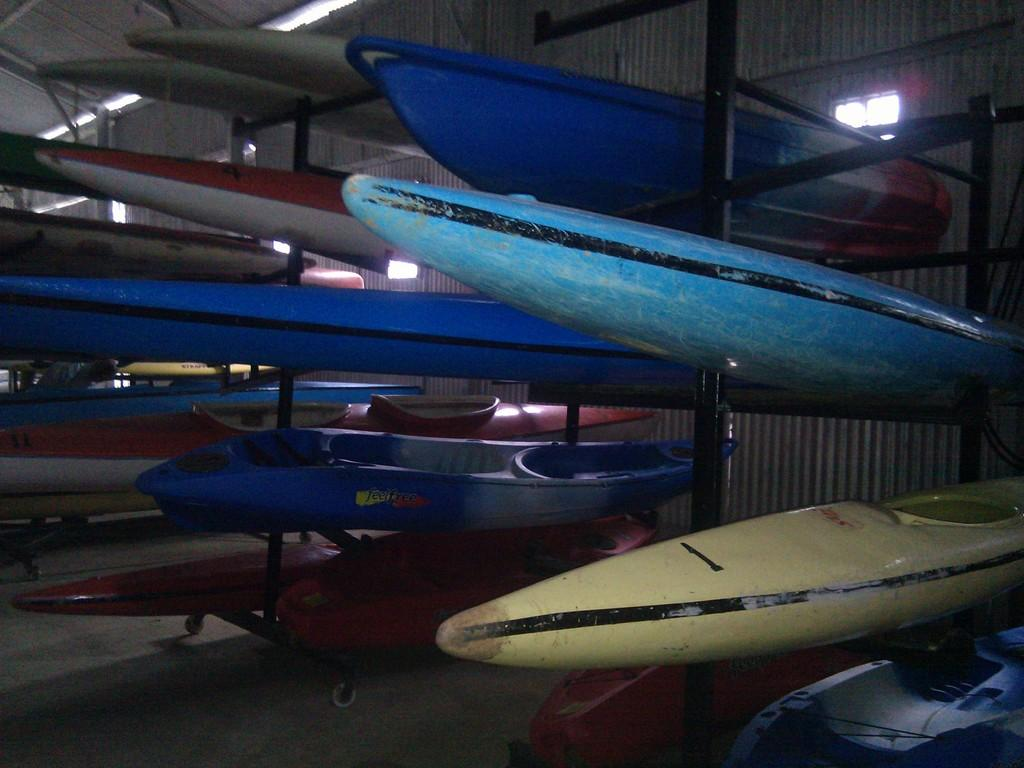What type of equipment is visible in the image? There are kayaking boards in the image. Where are the kayaking boards located? The kayaking boards are in the middle of the image. What can be seen in the background of the image? There is a wall in the background of the image. What type of treatment is being administered to the kayaking boards in the image? There is no treatment being administered to the kayaking boards in the image; they are simply visible in their current state. 